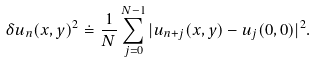Convert formula to latex. <formula><loc_0><loc_0><loc_500><loc_500>\delta u _ { n } ( x , y ) ^ { 2 } \doteq \frac { 1 } { N } \sum _ { j = 0 } ^ { N - 1 } | u _ { n + j } ( x , y ) - u _ { j } ( 0 , 0 ) | ^ { 2 } .</formula> 